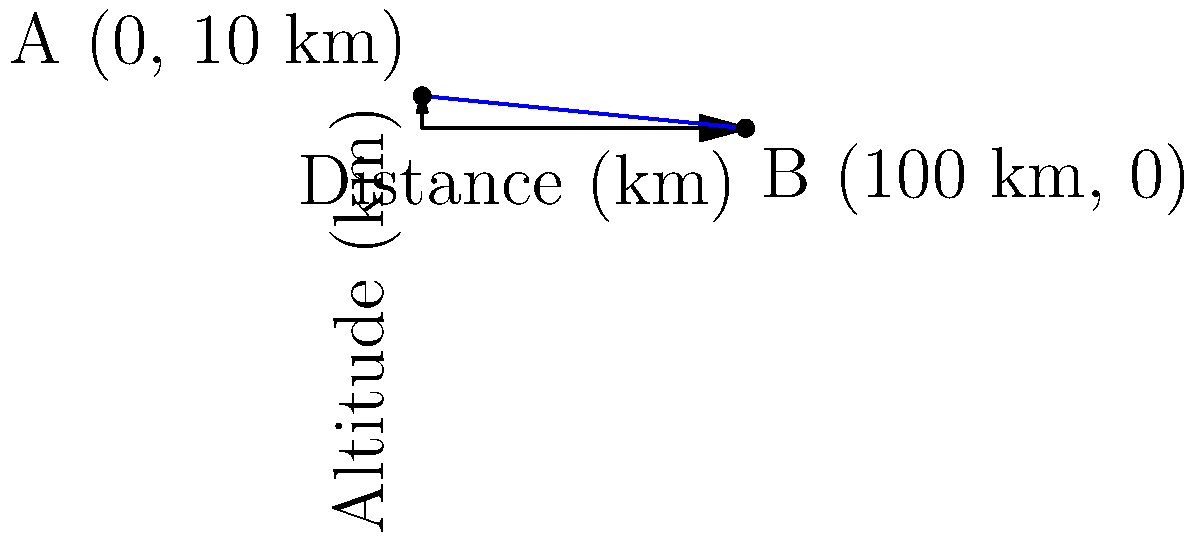As a pilot, you're conducting a glide test in an aircraft. You begin at point A, at an altitude of 10 km, and glide to point B on the ground, covering a horizontal distance of 100 km. Calculate the glide ratio of the aircraft. To calculate the glide ratio, we need to follow these steps:

1) The glide ratio is defined as the horizontal distance traveled divided by the altitude lost.

2) In this case:
   - Initial altitude: 10 km
   - Final altitude: 0 km
   - Horizontal distance traveled: 100 km

3) Altitude lost = Initial altitude - Final altitude
   $$ \text{Altitude lost} = 10 \text{ km} - 0 \text{ km} = 10 \text{ km} $$

4) Glide ratio = Horizontal distance / Altitude lost
   $$ \text{Glide ratio} = \frac{100 \text{ km}}{10 \text{ km}} = 10 $$

5) This means the aircraft travels 10 units horizontally for every 1 unit of altitude lost.

6) In pilot terms, this is often expressed as 10:1.
Answer: 10:1 